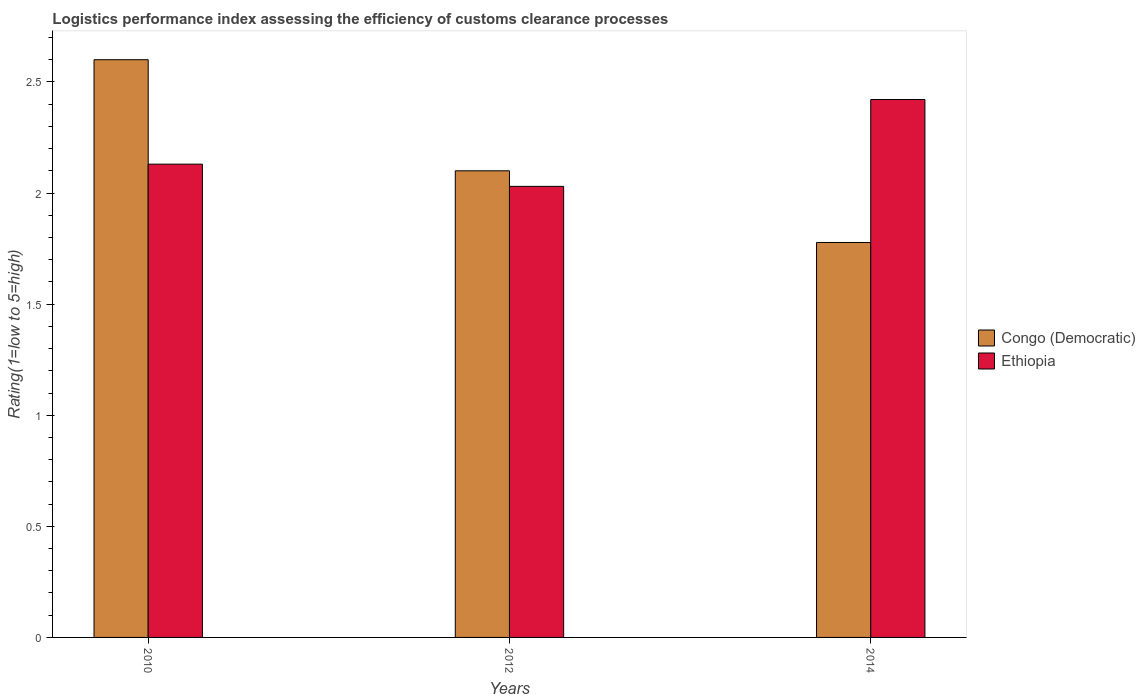How many different coloured bars are there?
Provide a succinct answer. 2. How many bars are there on the 2nd tick from the right?
Offer a very short reply. 2. In how many cases, is the number of bars for a given year not equal to the number of legend labels?
Offer a very short reply. 0. What is the Logistic performance index in Congo (Democratic) in 2014?
Make the answer very short. 1.78. Across all years, what is the maximum Logistic performance index in Ethiopia?
Make the answer very short. 2.42. Across all years, what is the minimum Logistic performance index in Ethiopia?
Your answer should be compact. 2.03. In which year was the Logistic performance index in Congo (Democratic) maximum?
Provide a short and direct response. 2010. In which year was the Logistic performance index in Congo (Democratic) minimum?
Keep it short and to the point. 2014. What is the total Logistic performance index in Congo (Democratic) in the graph?
Provide a short and direct response. 6.48. What is the difference between the Logistic performance index in Ethiopia in 2010 and that in 2014?
Offer a very short reply. -0.29. What is the difference between the Logistic performance index in Congo (Democratic) in 2010 and the Logistic performance index in Ethiopia in 2014?
Ensure brevity in your answer.  0.18. What is the average Logistic performance index in Congo (Democratic) per year?
Offer a very short reply. 2.16. In the year 2012, what is the difference between the Logistic performance index in Ethiopia and Logistic performance index in Congo (Democratic)?
Your response must be concise. -0.07. What is the ratio of the Logistic performance index in Congo (Democratic) in 2012 to that in 2014?
Ensure brevity in your answer.  1.18. Is the difference between the Logistic performance index in Ethiopia in 2010 and 2014 greater than the difference between the Logistic performance index in Congo (Democratic) in 2010 and 2014?
Your answer should be very brief. No. What is the difference between the highest and the second highest Logistic performance index in Ethiopia?
Make the answer very short. 0.29. What is the difference between the highest and the lowest Logistic performance index in Ethiopia?
Offer a terse response. 0.39. In how many years, is the Logistic performance index in Ethiopia greater than the average Logistic performance index in Ethiopia taken over all years?
Ensure brevity in your answer.  1. Is the sum of the Logistic performance index in Ethiopia in 2010 and 2014 greater than the maximum Logistic performance index in Congo (Democratic) across all years?
Provide a succinct answer. Yes. What does the 1st bar from the left in 2010 represents?
Provide a succinct answer. Congo (Democratic). What does the 2nd bar from the right in 2010 represents?
Give a very brief answer. Congo (Democratic). Are all the bars in the graph horizontal?
Keep it short and to the point. No. How many years are there in the graph?
Make the answer very short. 3. What is the difference between two consecutive major ticks on the Y-axis?
Give a very brief answer. 0.5. Are the values on the major ticks of Y-axis written in scientific E-notation?
Your answer should be compact. No. Does the graph contain any zero values?
Your answer should be very brief. No. Does the graph contain grids?
Your response must be concise. No. How many legend labels are there?
Provide a short and direct response. 2. How are the legend labels stacked?
Make the answer very short. Vertical. What is the title of the graph?
Make the answer very short. Logistics performance index assessing the efficiency of customs clearance processes. Does "Algeria" appear as one of the legend labels in the graph?
Provide a succinct answer. No. What is the label or title of the Y-axis?
Your response must be concise. Rating(1=low to 5=high). What is the Rating(1=low to 5=high) of Ethiopia in 2010?
Provide a short and direct response. 2.13. What is the Rating(1=low to 5=high) in Congo (Democratic) in 2012?
Ensure brevity in your answer.  2.1. What is the Rating(1=low to 5=high) of Ethiopia in 2012?
Make the answer very short. 2.03. What is the Rating(1=low to 5=high) of Congo (Democratic) in 2014?
Make the answer very short. 1.78. What is the Rating(1=low to 5=high) in Ethiopia in 2014?
Offer a terse response. 2.42. Across all years, what is the maximum Rating(1=low to 5=high) in Congo (Democratic)?
Give a very brief answer. 2.6. Across all years, what is the maximum Rating(1=low to 5=high) of Ethiopia?
Your answer should be very brief. 2.42. Across all years, what is the minimum Rating(1=low to 5=high) of Congo (Democratic)?
Keep it short and to the point. 1.78. Across all years, what is the minimum Rating(1=low to 5=high) in Ethiopia?
Keep it short and to the point. 2.03. What is the total Rating(1=low to 5=high) in Congo (Democratic) in the graph?
Your response must be concise. 6.48. What is the total Rating(1=low to 5=high) of Ethiopia in the graph?
Offer a very short reply. 6.58. What is the difference between the Rating(1=low to 5=high) of Congo (Democratic) in 2010 and that in 2012?
Keep it short and to the point. 0.5. What is the difference between the Rating(1=low to 5=high) in Congo (Democratic) in 2010 and that in 2014?
Provide a short and direct response. 0.82. What is the difference between the Rating(1=low to 5=high) of Ethiopia in 2010 and that in 2014?
Provide a succinct answer. -0.29. What is the difference between the Rating(1=low to 5=high) of Congo (Democratic) in 2012 and that in 2014?
Your answer should be very brief. 0.32. What is the difference between the Rating(1=low to 5=high) in Ethiopia in 2012 and that in 2014?
Make the answer very short. -0.39. What is the difference between the Rating(1=low to 5=high) of Congo (Democratic) in 2010 and the Rating(1=low to 5=high) of Ethiopia in 2012?
Your answer should be very brief. 0.57. What is the difference between the Rating(1=low to 5=high) in Congo (Democratic) in 2010 and the Rating(1=low to 5=high) in Ethiopia in 2014?
Offer a terse response. 0.18. What is the difference between the Rating(1=low to 5=high) of Congo (Democratic) in 2012 and the Rating(1=low to 5=high) of Ethiopia in 2014?
Make the answer very short. -0.32. What is the average Rating(1=low to 5=high) of Congo (Democratic) per year?
Provide a succinct answer. 2.16. What is the average Rating(1=low to 5=high) of Ethiopia per year?
Provide a short and direct response. 2.19. In the year 2010, what is the difference between the Rating(1=low to 5=high) of Congo (Democratic) and Rating(1=low to 5=high) of Ethiopia?
Your answer should be very brief. 0.47. In the year 2012, what is the difference between the Rating(1=low to 5=high) in Congo (Democratic) and Rating(1=low to 5=high) in Ethiopia?
Provide a succinct answer. 0.07. In the year 2014, what is the difference between the Rating(1=low to 5=high) in Congo (Democratic) and Rating(1=low to 5=high) in Ethiopia?
Keep it short and to the point. -0.64. What is the ratio of the Rating(1=low to 5=high) of Congo (Democratic) in 2010 to that in 2012?
Keep it short and to the point. 1.24. What is the ratio of the Rating(1=low to 5=high) of Ethiopia in 2010 to that in 2012?
Your answer should be very brief. 1.05. What is the ratio of the Rating(1=low to 5=high) in Congo (Democratic) in 2010 to that in 2014?
Provide a succinct answer. 1.46. What is the ratio of the Rating(1=low to 5=high) in Ethiopia in 2010 to that in 2014?
Provide a succinct answer. 0.88. What is the ratio of the Rating(1=low to 5=high) of Congo (Democratic) in 2012 to that in 2014?
Offer a very short reply. 1.18. What is the ratio of the Rating(1=low to 5=high) in Ethiopia in 2012 to that in 2014?
Your answer should be compact. 0.84. What is the difference between the highest and the second highest Rating(1=low to 5=high) in Ethiopia?
Offer a terse response. 0.29. What is the difference between the highest and the lowest Rating(1=low to 5=high) of Congo (Democratic)?
Provide a short and direct response. 0.82. What is the difference between the highest and the lowest Rating(1=low to 5=high) in Ethiopia?
Give a very brief answer. 0.39. 